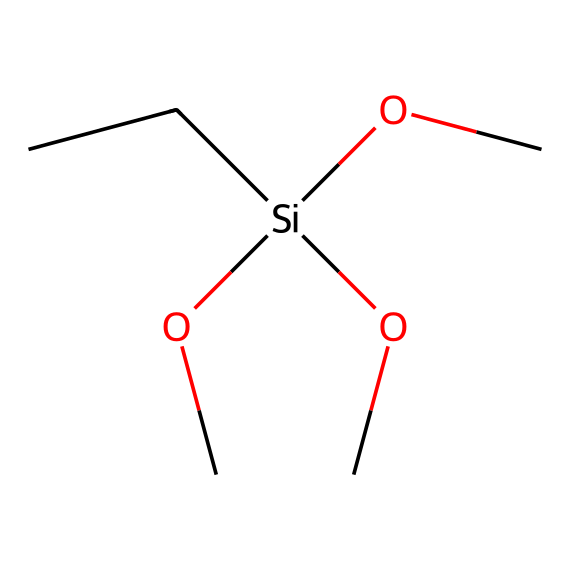What is the primary element in this silane? The primary element present in this silane is silicon, which is represented by the symbol 'Si' in the SMILES notation.
Answer: silicon How many oxygen atoms are present in this molecule? In the provided SMILES representation, there are three -O (oxygen) signs indicating the presence of three oxygen atoms bonded to silicon.
Answer: three What functional groups can be identified? The molecule contains alkoxy groups (represented as -O-R) in the form of three methoxy groups (-OCH3), indicating a silane coupling agent.
Answer: alkoxy What is the total number of carbon atoms in this compound? The SMILES shows four carbon atoms: three from the methoxy groups and one attached directly to silicon.
Answer: four Is this silane likely to be hydrophobic or hydrophilic? Due to the presence of three methoxy groups, which are polar, it is more likely to be hydrophilic overall, as these groups can engage in hydrogen bonding.
Answer: hydrophilic What type of bonding primarily exists between the silicon and oxygen? The bonding between silicon and oxygen in silanes is primarily covalent, as silicon shares electrons with oxygen atoms.
Answer: covalent 